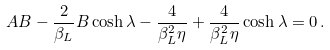<formula> <loc_0><loc_0><loc_500><loc_500>A B - \frac { 2 } { \beta _ { L } } B \cosh \lambda - \frac { 4 } { \beta _ { L } ^ { 2 } \eta } + \frac { 4 } { \beta _ { L } ^ { 2 } \eta } \cosh \lambda = 0 \, .</formula> 